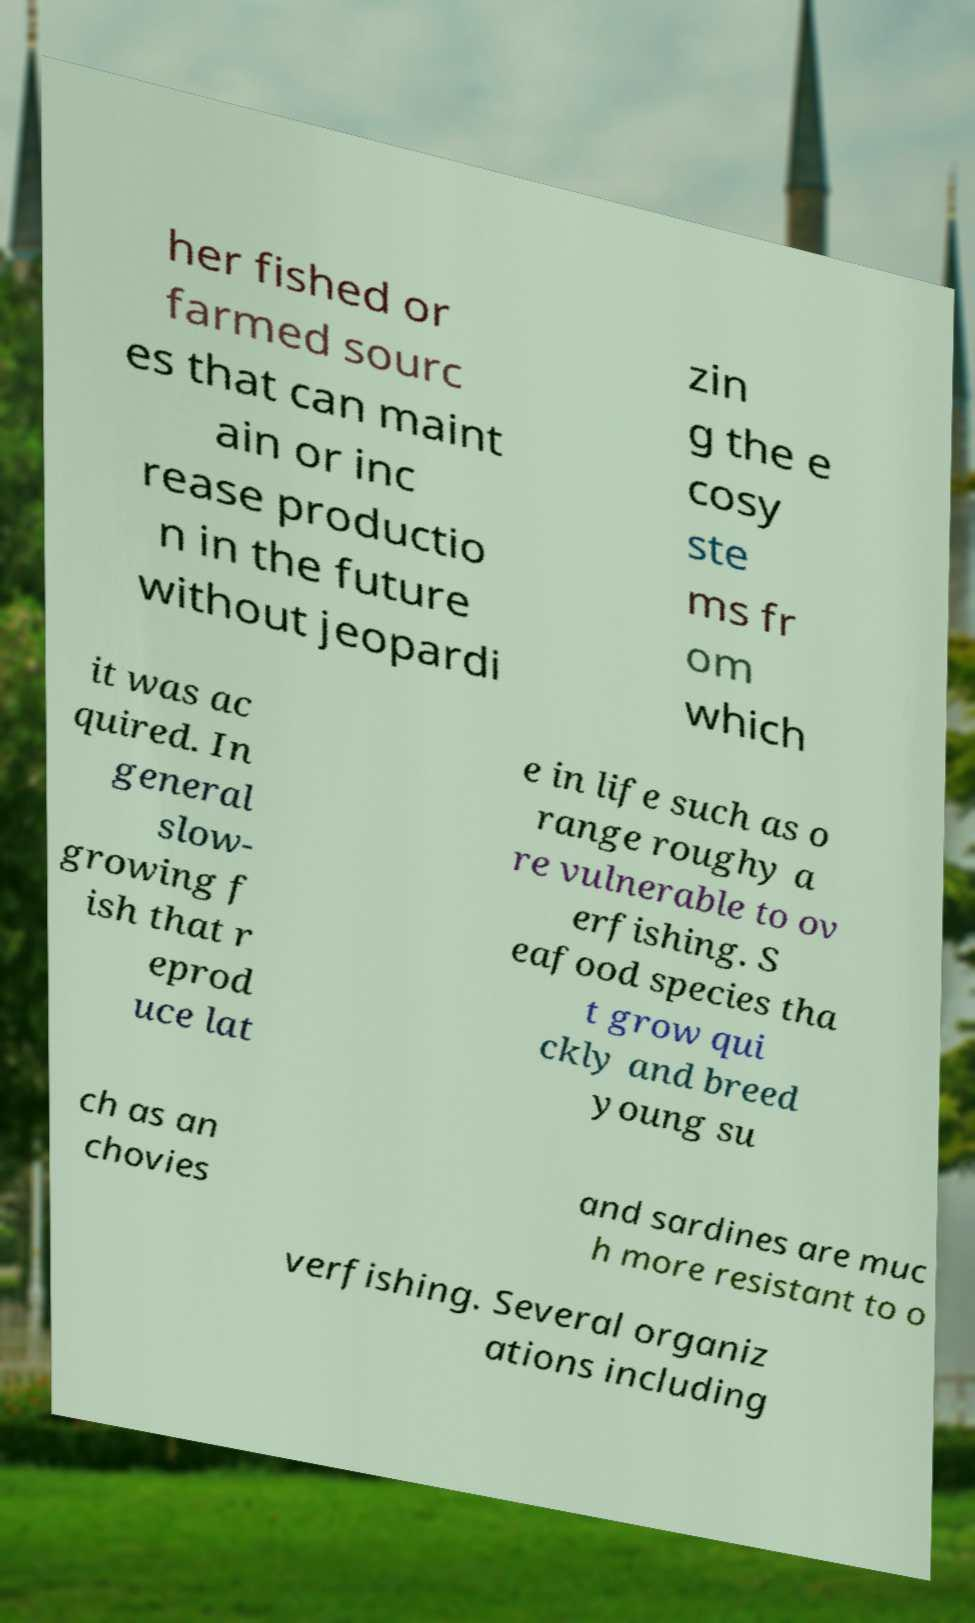Could you assist in decoding the text presented in this image and type it out clearly? her fished or farmed sourc es that can maint ain or inc rease productio n in the future without jeopardi zin g the e cosy ste ms fr om which it was ac quired. In general slow- growing f ish that r eprod uce lat e in life such as o range roughy a re vulnerable to ov erfishing. S eafood species tha t grow qui ckly and breed young su ch as an chovies and sardines are muc h more resistant to o verfishing. Several organiz ations including 